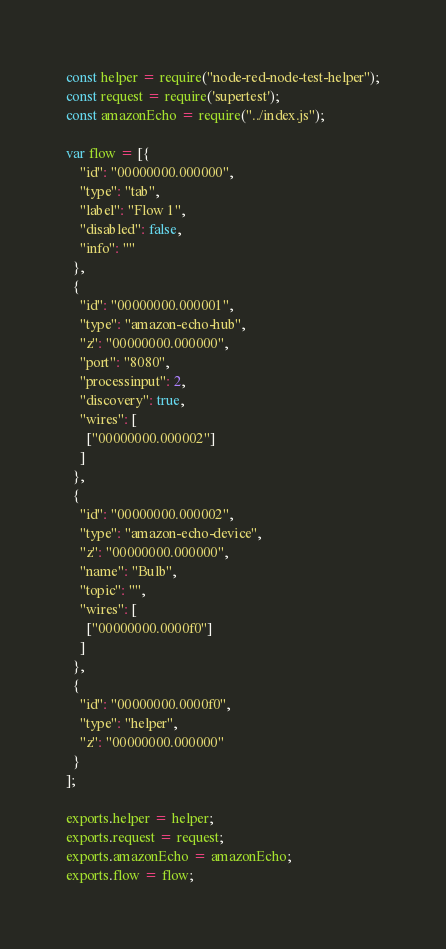Convert code to text. <code><loc_0><loc_0><loc_500><loc_500><_JavaScript_>const helper = require("node-red-node-test-helper");
const request = require('supertest');
const amazonEcho = require("../index.js");

var flow = [{
    "id": "00000000.000000",
    "type": "tab",
    "label": "Flow 1",
    "disabled": false,
    "info": ""
  },
  {
    "id": "00000000.000001",
    "type": "amazon-echo-hub",
    "z": "00000000.000000",
    "port": "8080",
    "processinput": 2,
    "discovery": true,
    "wires": [
      ["00000000.000002"]
    ]
  },
  {
    "id": "00000000.000002",
    "type": "amazon-echo-device",
    "z": "00000000.000000",
    "name": "Bulb",
    "topic": "",
    "wires": [
      ["00000000.0000f0"]
    ]
  },
  {
    "id": "00000000.0000f0",
    "type": "helper",
    "z": "00000000.000000"
  }
];

exports.helper = helper;
exports.request = request;
exports.amazonEcho = amazonEcho;
exports.flow = flow;
</code> 